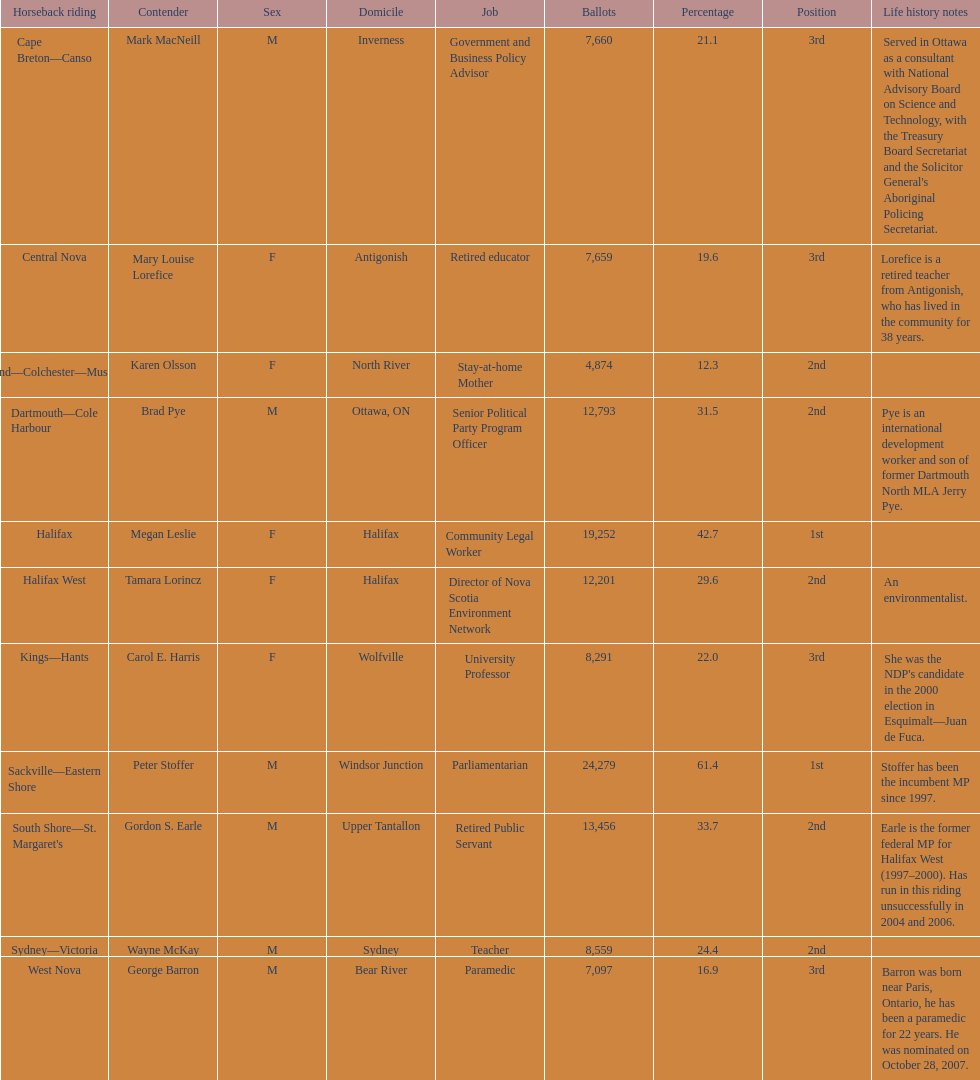What is the number of votes that megan leslie received? 19,252. 